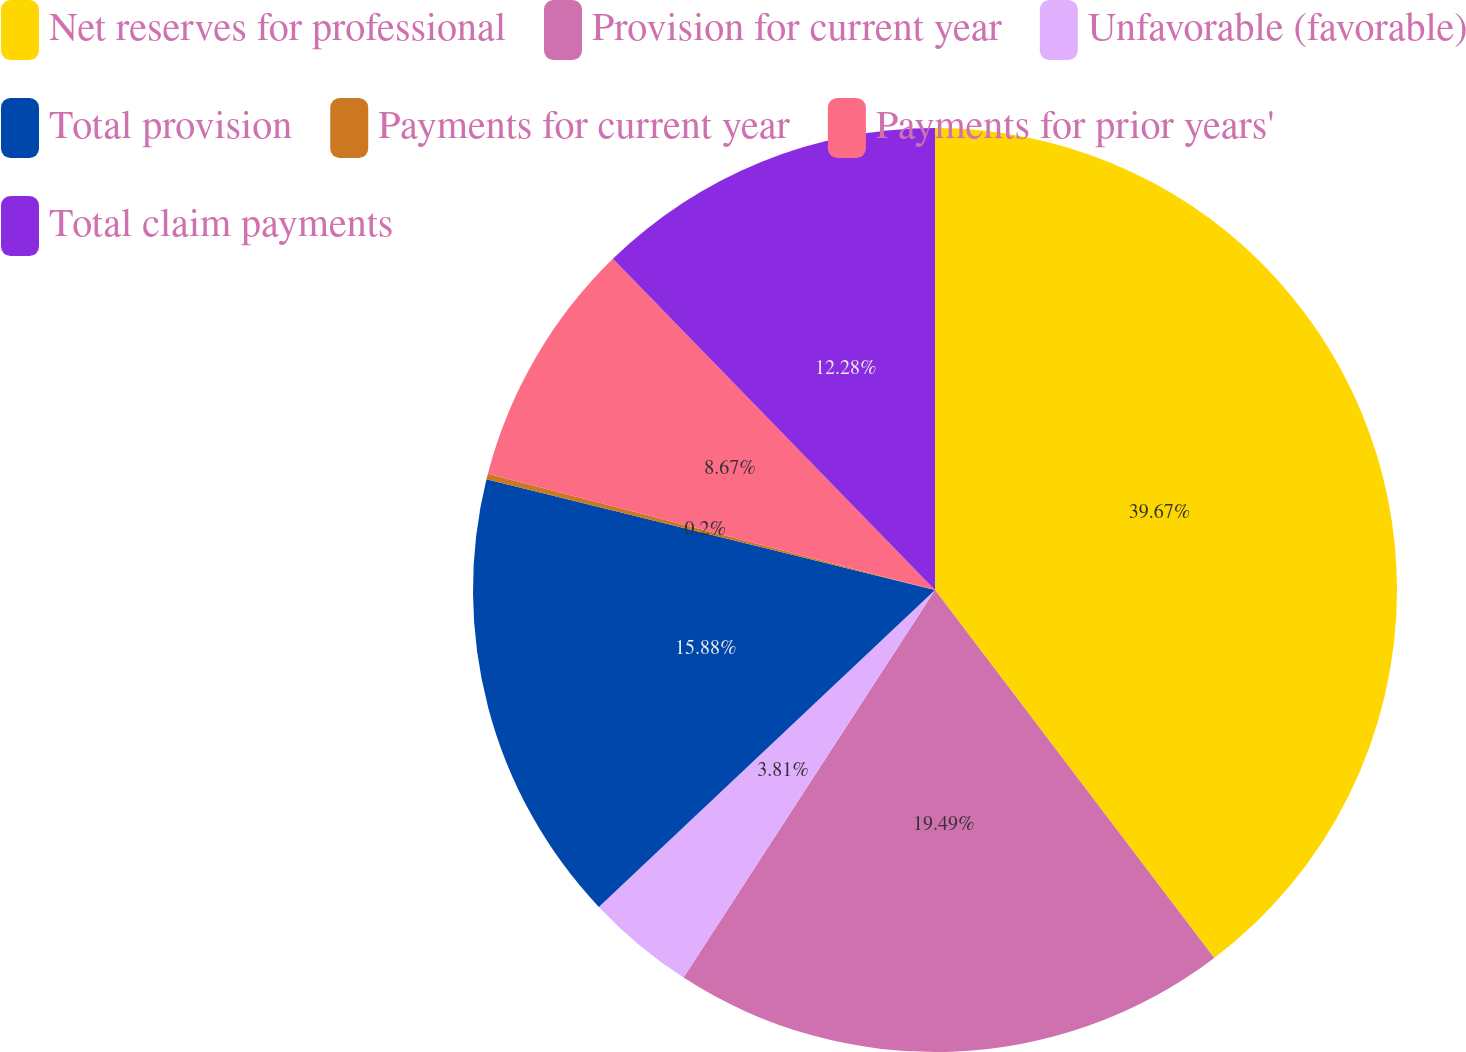Convert chart. <chart><loc_0><loc_0><loc_500><loc_500><pie_chart><fcel>Net reserves for professional<fcel>Provision for current year<fcel>Unfavorable (favorable)<fcel>Total provision<fcel>Payments for current year<fcel>Payments for prior years'<fcel>Total claim payments<nl><fcel>39.67%<fcel>19.49%<fcel>3.81%<fcel>15.88%<fcel>0.2%<fcel>8.67%<fcel>12.28%<nl></chart> 